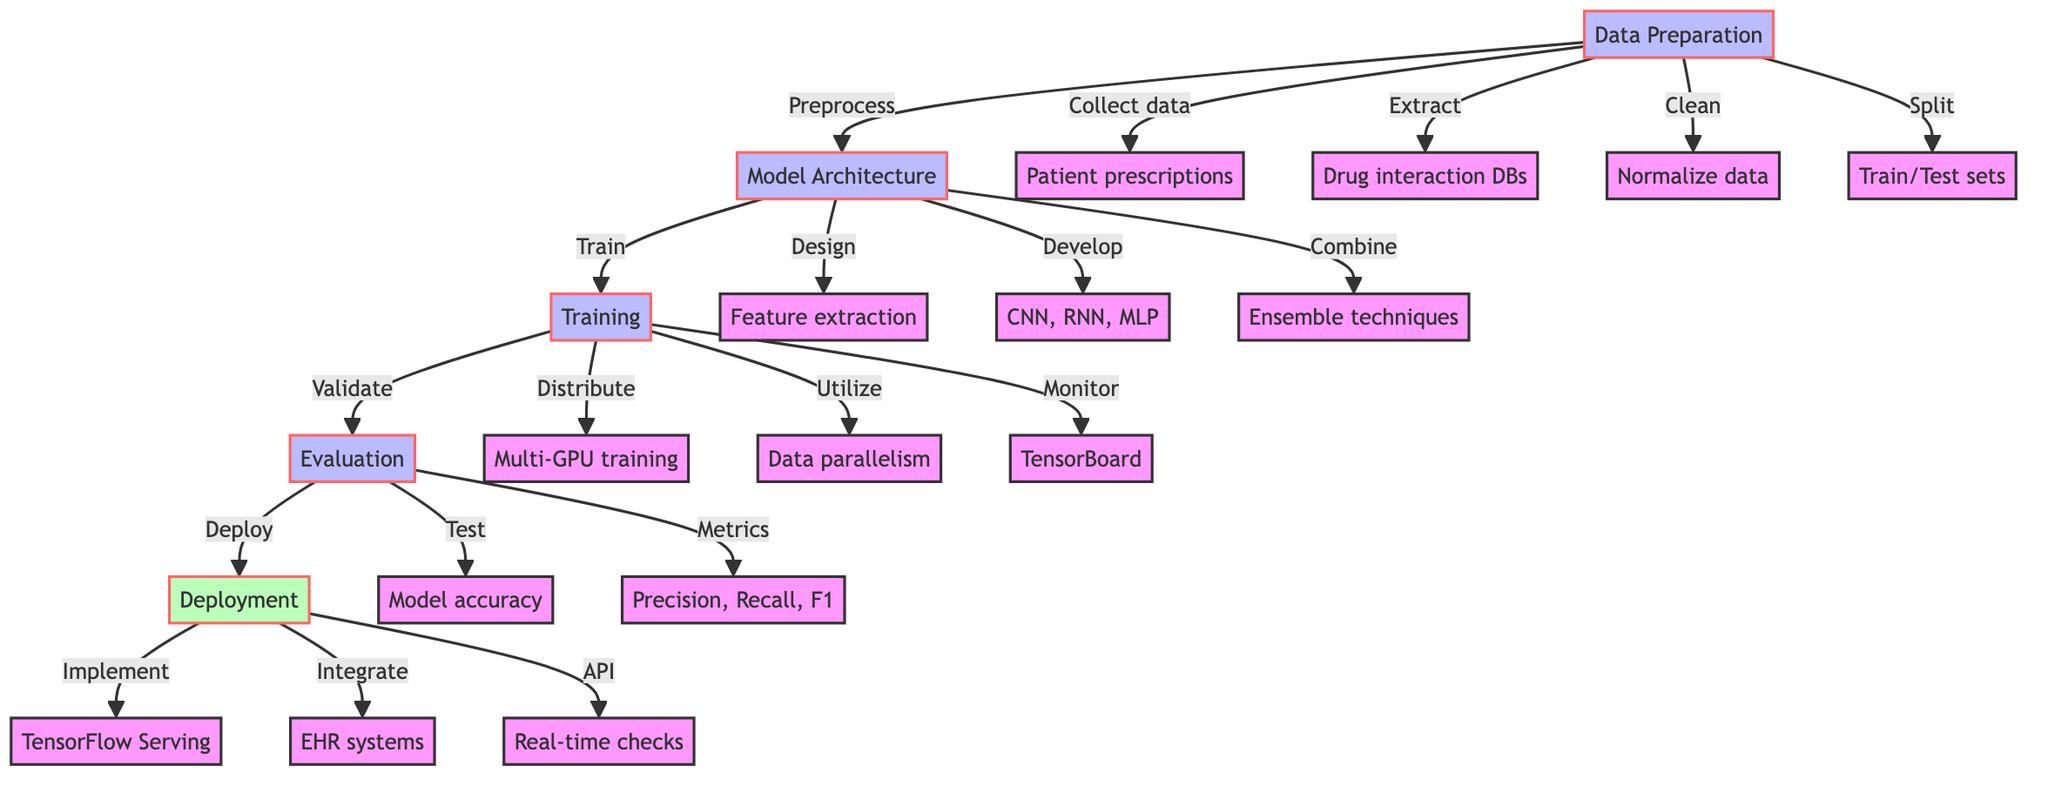What are the main phases in the clinical pathway? The diagram shows five main phases: Data Preparation, Model Architecture, Training, Evaluation, and Deployment. These can be identified as the top-level nodes in the flowchart.
Answer: Data Preparation, Model Architecture, Training, Evaluation, Deployment How many steps are involved in 'Data Preparation'? Under the 'Data Preparation' node, there are four distinct steps listed: Collect patient prescription data, Extract drug interaction databases, Normalize and clean data, and Split into training and test datasets.
Answer: Four Which node follows 'Model Architecture'? The flowchart specifies that 'Training' directly follows 'Model Architecture', which is indicated by an arrow connecting the two nodes.
Answer: Training What techniques are used in the 'Model Architecture'? The 'Model Architecture' node describes three techniques: CNN, RNN, and MLP, which are mentioned as part of the development of multiple neural network models.
Answer: CNN, RNN, MLP What is the last step in the clinical pathway? The final designated step in the clinical pathway, represented in the flowchart, is the 'Deployment' phase, which is the output of the entire process.
Answer: Deployment Name one method used to monitor the training process. The 'Training' phase includes monitoring training progress with TensorBoard, as indicated in the steps listed under that node.
Answer: TensorBoard What do the arrows in the diagram represent? The arrows in the diagram indicate the flow of the clinical pathway, showing the progression from one phase to another in a sequential manner.
Answer: Flow of the clinical pathway How is the model implemented in a clinical system? The 'Deployment' phase outlines several steps, and one of the key implementations is using TensorFlow Serving to deploy the model.
Answer: TensorFlow Serving What type of data parallelism is utilized during training? The 'Training' node mentions that data parallelism is utilized to increase the efficiency and speed of the training process among multiple computational units.
Answer: Data parallelism 